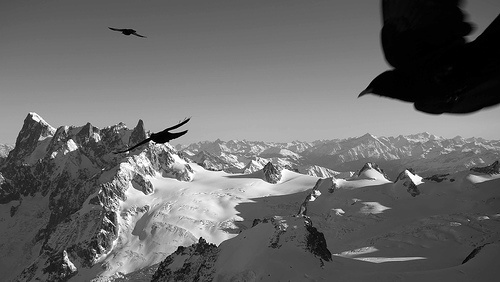Describe the objects in this image and their specific colors. I can see bird in gray and black tones, bird in black and gray tones, and bird in black and gray tones in this image. 